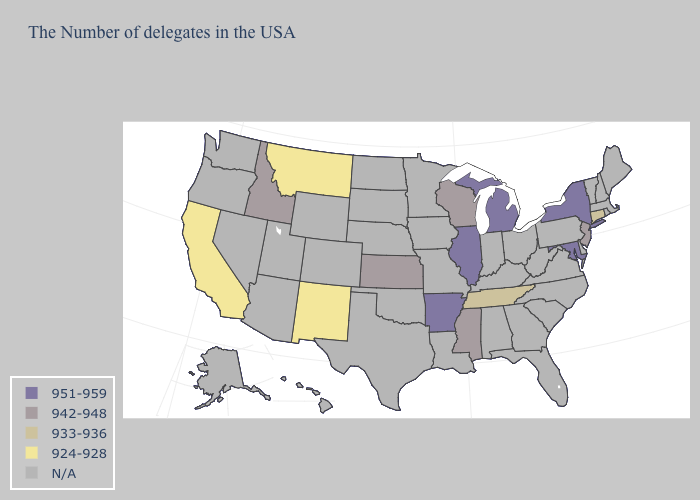Name the states that have a value in the range 942-948?
Give a very brief answer. New Jersey, Wisconsin, Mississippi, Kansas, Idaho. Does the map have missing data?
Concise answer only. Yes. Name the states that have a value in the range 951-959?
Quick response, please. New York, Maryland, Michigan, Illinois, Arkansas. How many symbols are there in the legend?
Quick response, please. 5. How many symbols are there in the legend?
Short answer required. 5. What is the value of West Virginia?
Short answer required. N/A. Which states hav the highest value in the MidWest?
Short answer required. Michigan, Illinois. Which states have the lowest value in the South?
Short answer required. Tennessee. Which states hav the highest value in the Northeast?
Short answer required. New York. How many symbols are there in the legend?
Be succinct. 5. Among the states that border North Dakota , which have the lowest value?
Keep it brief. Montana. Does the map have missing data?
Keep it brief. Yes. What is the value of North Dakota?
Answer briefly. N/A. 